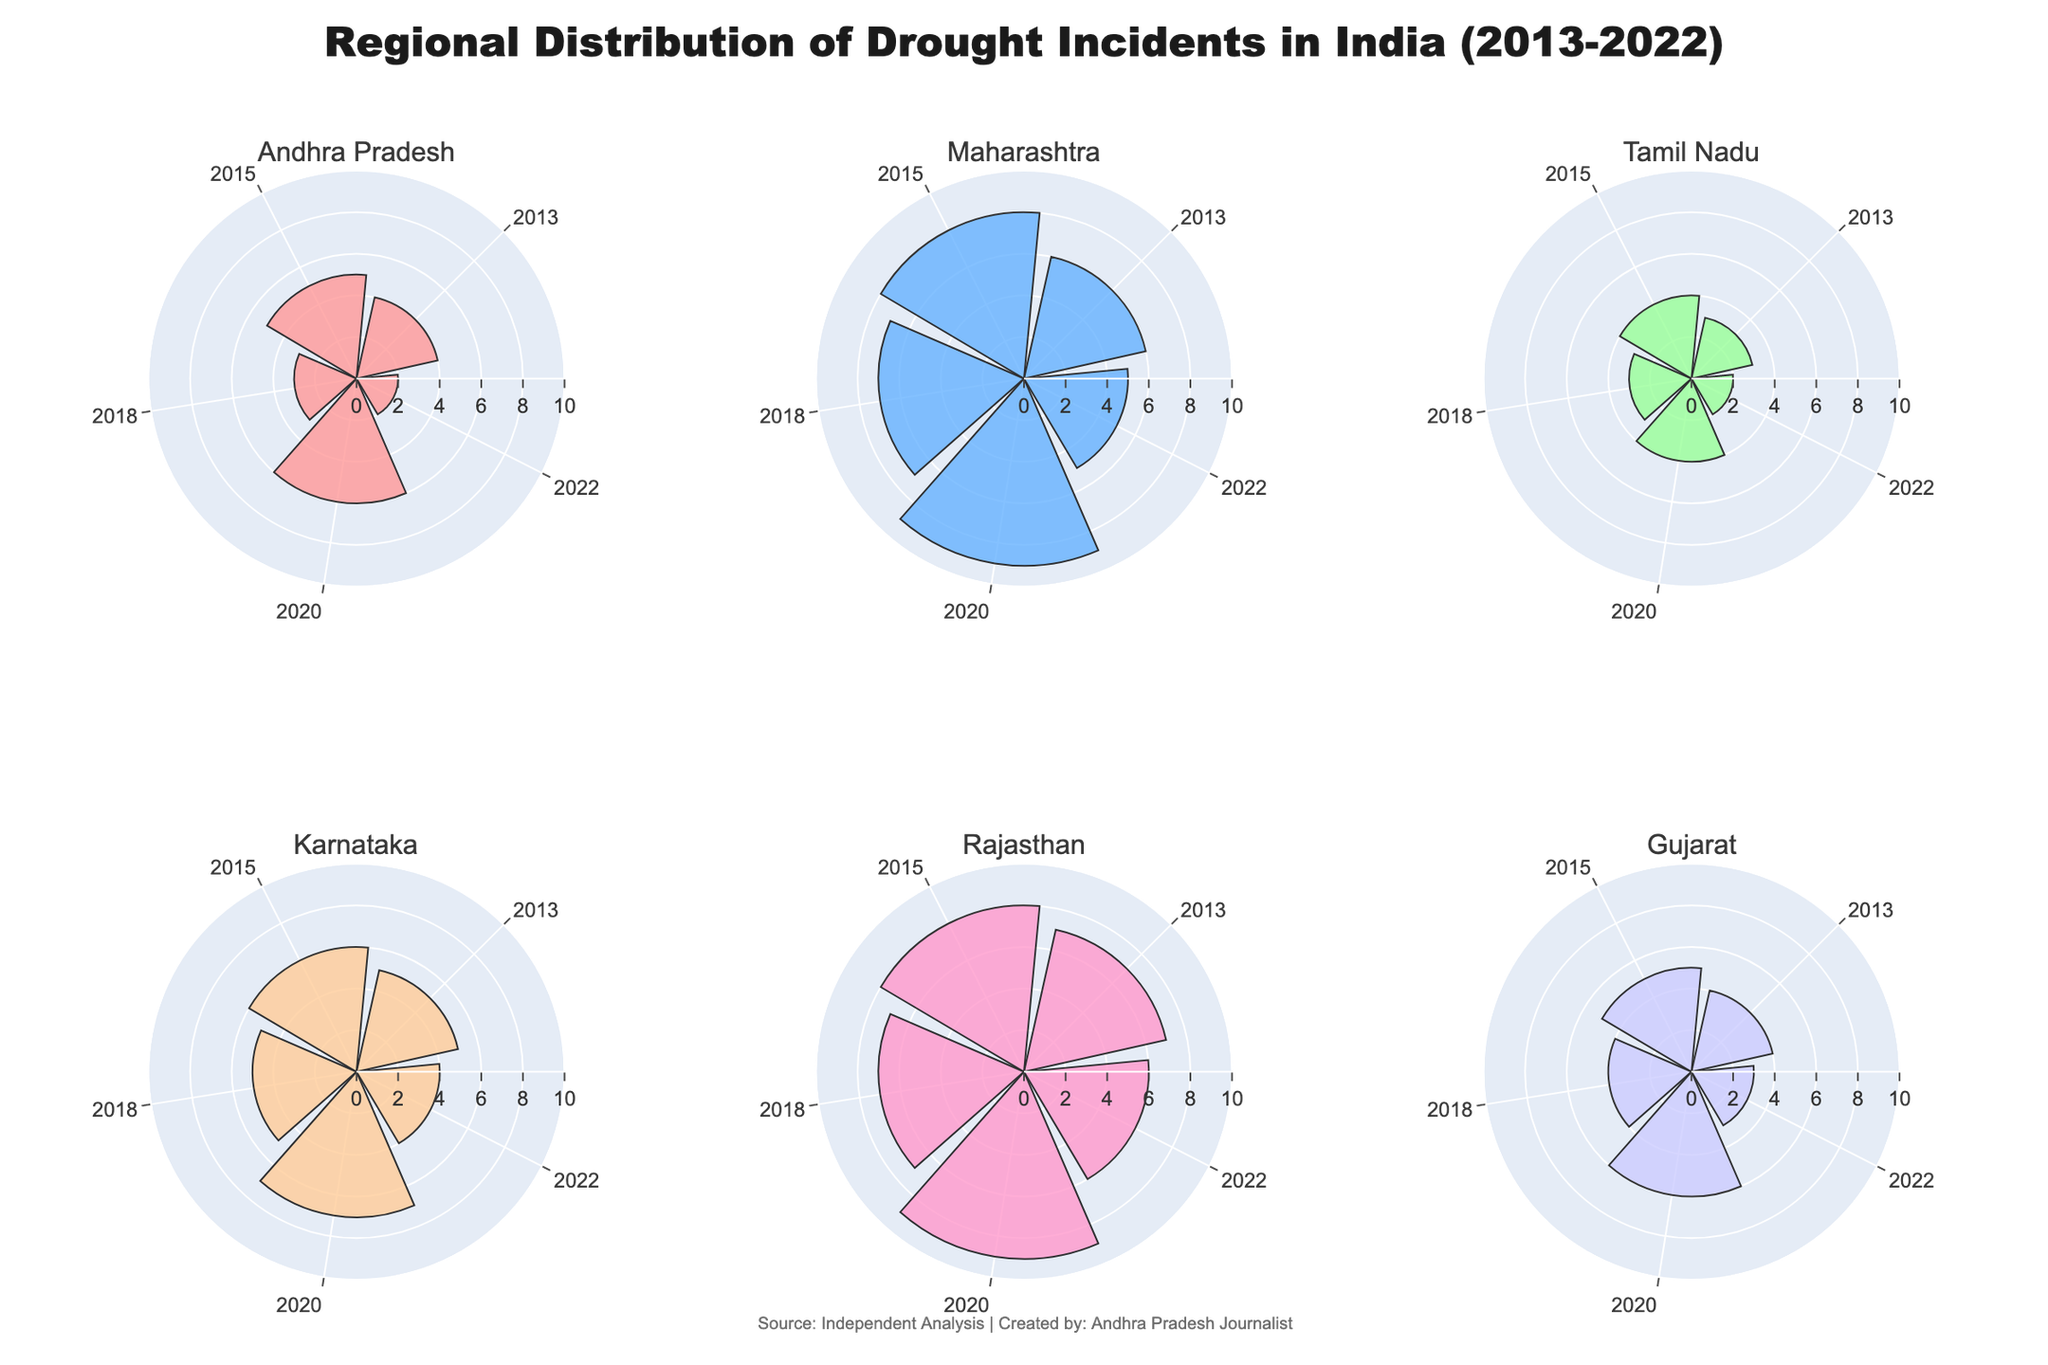What is the title of the figure? The title is typically located at the top of the figure and gives an overview of what the figure represents. In this case, it can be found in the layout settings of the plot.
Answer: "Regional Distribution of Drought Incidents in India (2013-2022)" In which year did Andhra Pradesh experience the highest number of drought incidents? Look at the sub-plot for Andhra Pradesh and identify the bar segment with the longest length (highest value) and then check the corresponding year label.
Answer: 2020 Which region experienced the highest number of drought incidents in 2018? Compare the lengths of the bars corresponding to the year 2018 in each of the sub-plots for all regions. The longest bar indicates the highest number of incidents.
Answer: Maharashtra What is the total number of drought incidents in Maharashtra from 2013 to 2022? Add up the values of the bars representing Maharashtra across all years shown in the plot.
Answer: 35 Which region had the most consistent number of drought incidents over the decade? Consistency can be judged by the similarity in the length of bars from year to year within each region's sub-plot. Identify the region with the least variation in bar lengths.
Answer: Tamil Nadu What is the range of drought incidents observed in Gujarat? Calculate the range by subtracting the lowest value from the highest value of drought incidents in the Gujarat sub-plot.
Answer: 3 How many regions experienced an increase in drought incidents in 2015 compared to 2013? For each region, compare the bar lengths between the years 2013 and 2015 to identify whether there was an increase. Count the regions with increased values.
Answer: 5 Which year had the highest combined number of drought incidents across all regions? Sum the drought incident values for all regions for each year and identify which year has the highest total.
Answer: 2020 